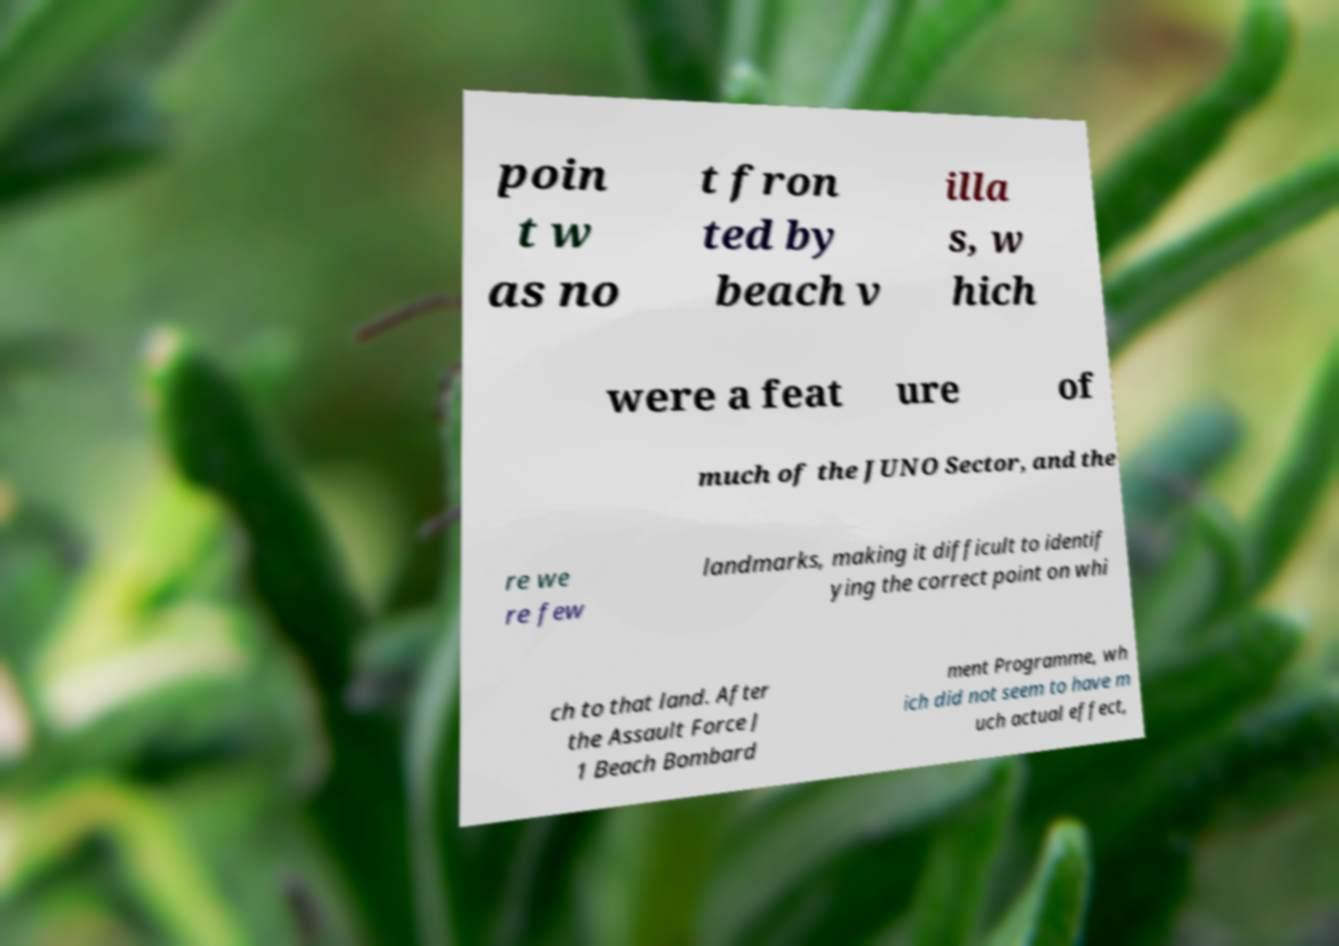Could you extract and type out the text from this image? poin t w as no t fron ted by beach v illa s, w hich were a feat ure of much of the JUNO Sector, and the re we re few landmarks, making it difficult to identif ying the correct point on whi ch to that land. After the Assault Force J 1 Beach Bombard ment Programme, wh ich did not seem to have m uch actual effect, 